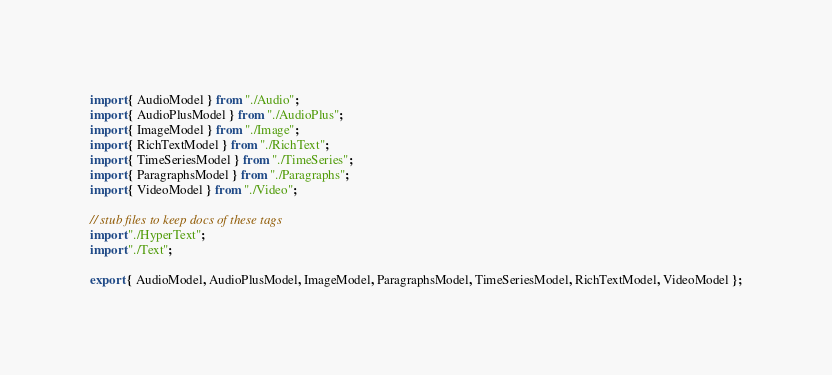Convert code to text. <code><loc_0><loc_0><loc_500><loc_500><_JavaScript_>import { AudioModel } from "./Audio";
import { AudioPlusModel } from "./AudioPlus";
import { ImageModel } from "./Image";
import { RichTextModel } from "./RichText";
import { TimeSeriesModel } from "./TimeSeries";
import { ParagraphsModel } from "./Paragraphs";
import { VideoModel } from "./Video";

// stub files to keep docs of these tags
import "./HyperText";
import "./Text";

export { AudioModel, AudioPlusModel, ImageModel, ParagraphsModel, TimeSeriesModel, RichTextModel, VideoModel };
</code> 